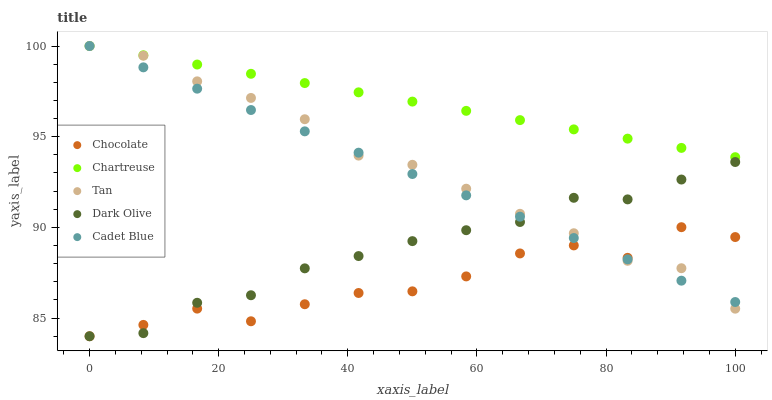Does Chocolate have the minimum area under the curve?
Answer yes or no. Yes. Does Chartreuse have the maximum area under the curve?
Answer yes or no. Yes. Does Dark Olive have the minimum area under the curve?
Answer yes or no. No. Does Dark Olive have the maximum area under the curve?
Answer yes or no. No. Is Chartreuse the smoothest?
Answer yes or no. Yes. Is Chocolate the roughest?
Answer yes or no. Yes. Is Dark Olive the smoothest?
Answer yes or no. No. Is Dark Olive the roughest?
Answer yes or no. No. Does Dark Olive have the lowest value?
Answer yes or no. Yes. Does Chartreuse have the lowest value?
Answer yes or no. No. Does Tan have the highest value?
Answer yes or no. Yes. Does Dark Olive have the highest value?
Answer yes or no. No. Is Dark Olive less than Chartreuse?
Answer yes or no. Yes. Is Chartreuse greater than Dark Olive?
Answer yes or no. Yes. Does Tan intersect Chartreuse?
Answer yes or no. Yes. Is Tan less than Chartreuse?
Answer yes or no. No. Is Tan greater than Chartreuse?
Answer yes or no. No. Does Dark Olive intersect Chartreuse?
Answer yes or no. No. 